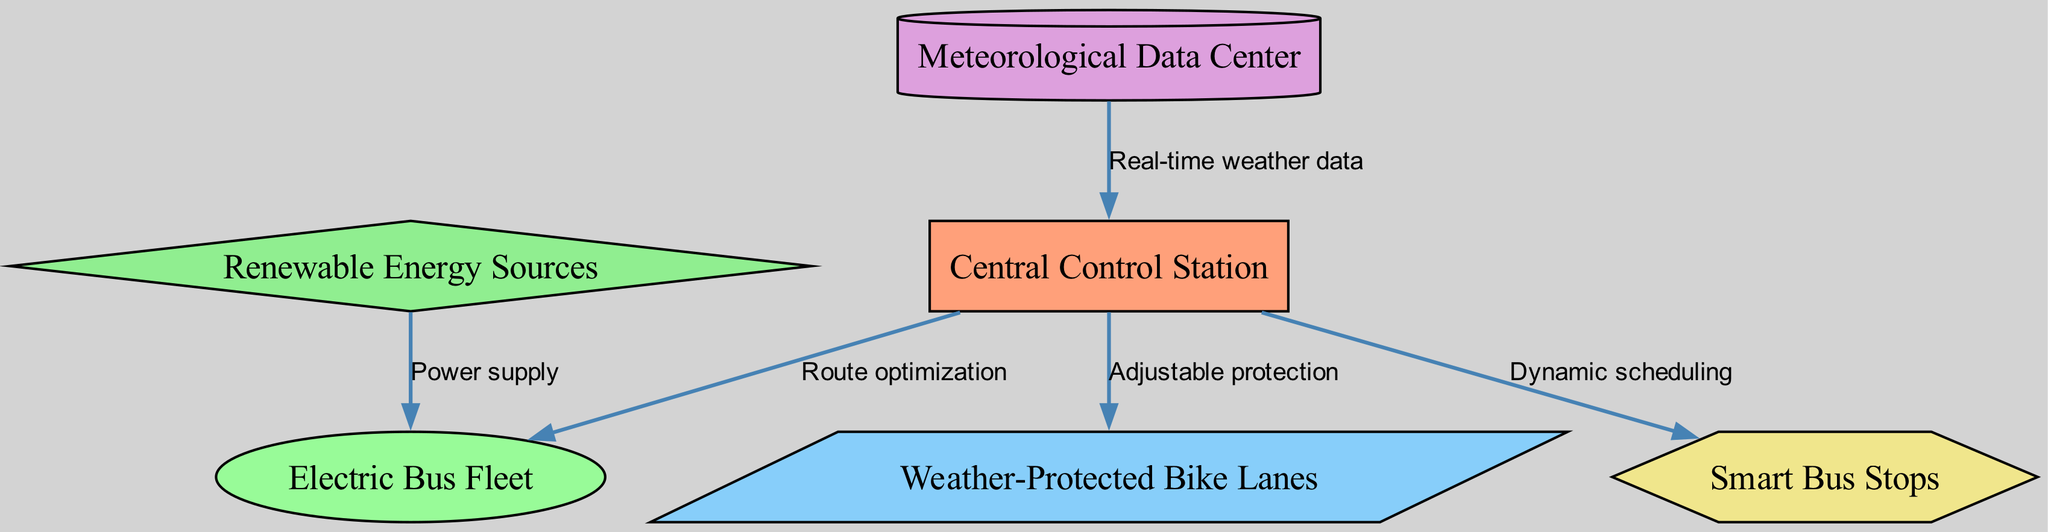What is the total number of nodes in the diagram? The diagram contains six nodes: Central Control Station, Electric Bus Fleet, Weather-Protected Bike Lanes, Meteorological Data Center, Smart Bus Stops, and Renewable Energy Sources. Therefore, the total number of nodes is obtained by counting each unique node listed.
Answer: 6 Which node receives real-time weather data? The diagram indicates that the Meteorological Data Center sends real-time weather data to the Central Control Station. This can be deduced by identifying the edge labeled "Real-time weather data" which originates from node 4 (Meteorological Data Center) and points to node 1 (Central Control Station).
Answer: Central Control Station How many edges are present in the diagram? The diagram includes five edges connecting the nodes. By examining the connections listed, each labeled relationship between nodes is counted to determine the total number of edges.
Answer: 5 What is the relationship labeled for the connection from the Central Control Station to the Electric Bus Fleet? In the diagram, the connection from the Central Control Station (node 1) to the Electric Bus Fleet (node 2) is labeled as "Route optimization." This can be confirmed by looking for the edge that points from node 1 to node 2 with the specific label attached.
Answer: Route optimization Which node supplies power to the Electric Bus Fleet? The Renewable Energy Sources node provides power to the Electric Bus Fleet, as indicated by the edge connecting node 6 to node 2 with the label "Power supply." By following the connection from the source node to the bus fleet node, the answer is derived.
Answer: Renewable Energy Sources What kind of data is used for dynamic scheduling? Dynamic scheduling is oriented from the Central Control Station to the Smart Bus Stops. The linking edge labeled "Dynamic scheduling" suggests that it is related to the operational data provided by the control station. By analyzing the flow, one can identify that it is orchestrated through the Central Control Station.
Answer: Central Control Station Which node is responsible for adjustable protection for bike lanes? The adjustable protection for the Weather-Protected Bike Lanes is managed by the Central Control Station as indicated by the directed edge labeled "Adjustable protection" that points from node 1 to node 3. This shows that the control station oversees this aspect of the bike lane management system.
Answer: Central Control Station What type of nodes are Smart Bus Stops represented as? Smart Bus Stops in the diagram are represented as hexagon-shaped nodes. Analyzing the node shapes shows that the distinct shape chosen for Smart Bus Stops is a hexagon, which can be validated by observing the specific shape assigned in the diagram.
Answer: Hexagon How many connections does the Meteorological Data Center have? The Meteorological Data Center (node 4) has one outgoing connection to the Central Control Station with the label "Real-time weather data." By examining all edges emanating from this node, it can be concluded that it only connects to one other node.
Answer: 1 